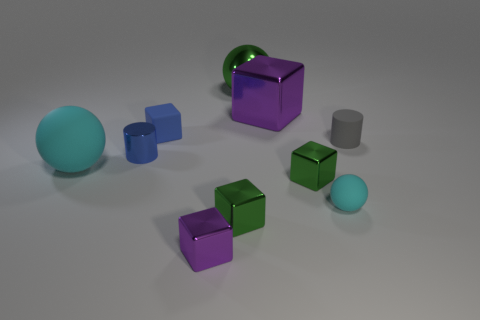There is a purple shiny cube that is in front of the matte cylinder; is its size the same as the blue rubber object?
Your answer should be very brief. Yes. Are there more green balls that are to the right of the metal sphere than tiny green objects?
Your answer should be compact. No. There is a large object left of the large green metal object; how many purple metallic blocks are behind it?
Provide a short and direct response. 1. Is the number of blocks that are left of the tiny blue rubber thing less than the number of tiny blue metallic objects?
Keep it short and to the point. Yes. Are there any small blue cylinders that are left of the matte thing that is in front of the cyan matte object that is behind the tiny cyan rubber object?
Your response must be concise. Yes. Do the gray object and the cylinder left of the large cube have the same material?
Offer a very short reply. No. The large sphere in front of the cylinder left of the tiny purple thing is what color?
Your answer should be compact. Cyan. Is there a thing of the same color as the large rubber ball?
Give a very brief answer. Yes. What size is the blue shiny thing behind the green object that is in front of the green block that is on the right side of the large purple metal thing?
Your response must be concise. Small. There is a small blue matte thing; is it the same shape as the purple object in front of the gray rubber object?
Provide a short and direct response. Yes. 